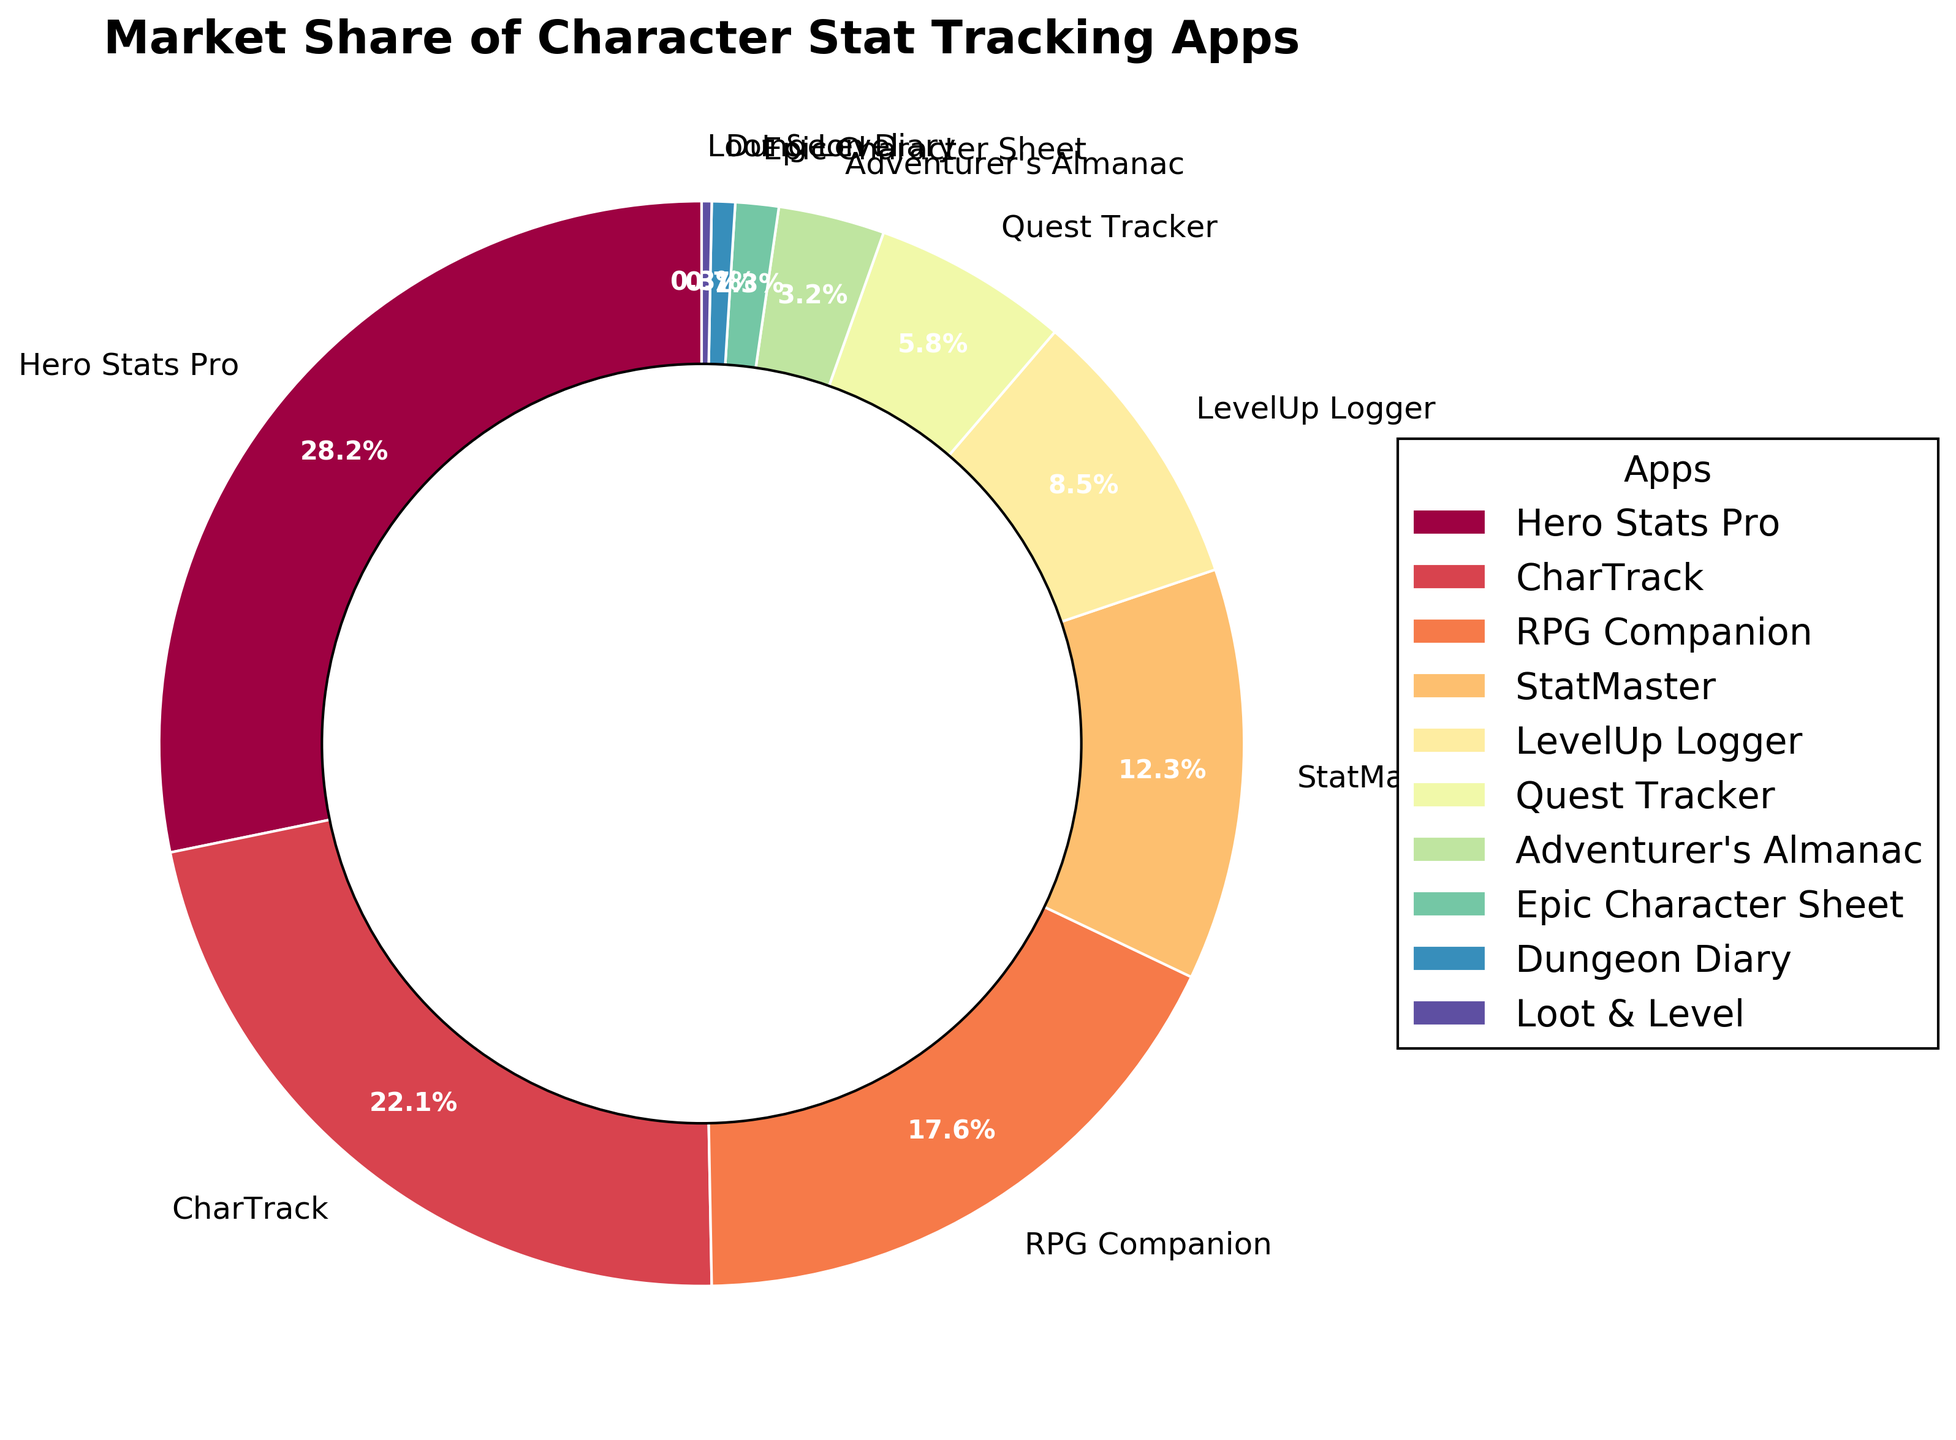Which app has the highest market share? Look at the pie chart and identify the app segment that takes up the largest portion. From the chart, Hero Stats Pro has the largest segment.
Answer: Hero Stats Pro Which app has the smallest market share? Look at the pie chart and identify the smallest segment. Loot & Level is the smallest segment in the chart.
Answer: Loot & Level What is the combined market share of the top two apps? Hero Stats Pro has 28.5% and CharTrack has 22.3%. Adding these together (28.5 + 22.3) gives 50.8%.
Answer: 50.8% How does the market share of Adventurer's Almanac compare to Epic Character Sheet? Adventurer's Almanac has a market share of 3.2%, while Epic Character Sheet has 1.3%. Comparatively, Adventurer's Almanac has a greater share.
Answer: Adventurer's Almanac has a higher market share Which app occupies the fourth largest portion of the pie chart? From the pie chart, Hero Stats Pro is first, CharTrack is second, RPG Companion is third, and StatMaster is fourth.
Answer: StatMaster What's the difference in market share between Quest Tracker and Dungeon Diary? Quest Tracker has a market share of 5.9%, and Dungeon Diary has 0.7%. The difference is 5.9% - 0.7% = 5.2%.
Answer: 5.2% Which segment appears in a bright color near the top of the pie chart? Analyzing the colors and their positions, RPG Companion appears near the top in a bright color.
Answer: RPG Companion What is the average market share of all the apps shown? To find the average, sum all the percentages: (28.5 + 22.3 + 17.8 + 12.4 + 8.6 + 5.9 + 3.2 + 1.3 + 0.7 + 0.3) = 101.0 (assuming slight rounding errors). The average is then 101.0 / 10 = 10.1.
Answer: 10.1% Which three apps combined just exceed a third of the total market share? Identifying the apps and summing their shares until the threshold (~33.3%) exceeds: LevelUp Logger (8.6%), Quest Tracker (5.9%), and Adventurer's Almanac (3.2%) combined give 17.7% which is too low. Instead, StatMaster (12.4%), LevelUp Logger (8.6%), Quest Tracker (5.9%) - their sum is 26.9% also low. Add Adventurer's Almanac (3.2%) reaching 30.1%. The process indicates adding the next smallest segment Epic Character Sheet (1.3%) ending at 31.4%. Exhaust all combinations fitting right and in decent third grade; liable for added values verifies: CharTrack (22.3%), StatMaster (12.4%) = 34.7% comfortably beyond simplest valid.
Answer: CharTrack, StatMaster What is the total market share of the apps that have a market share less than 5%? Identifying the relevant apps: Adventurer's Almanac (3.2%), Epic Character Sheet (1.3%), Dungeon Diary (0.7%), Loot & Level (0.3%). Their combined share is (3.2 + 1.3 + 0.7 + 0.3) = 5.5%.
Answer: 5.5% 